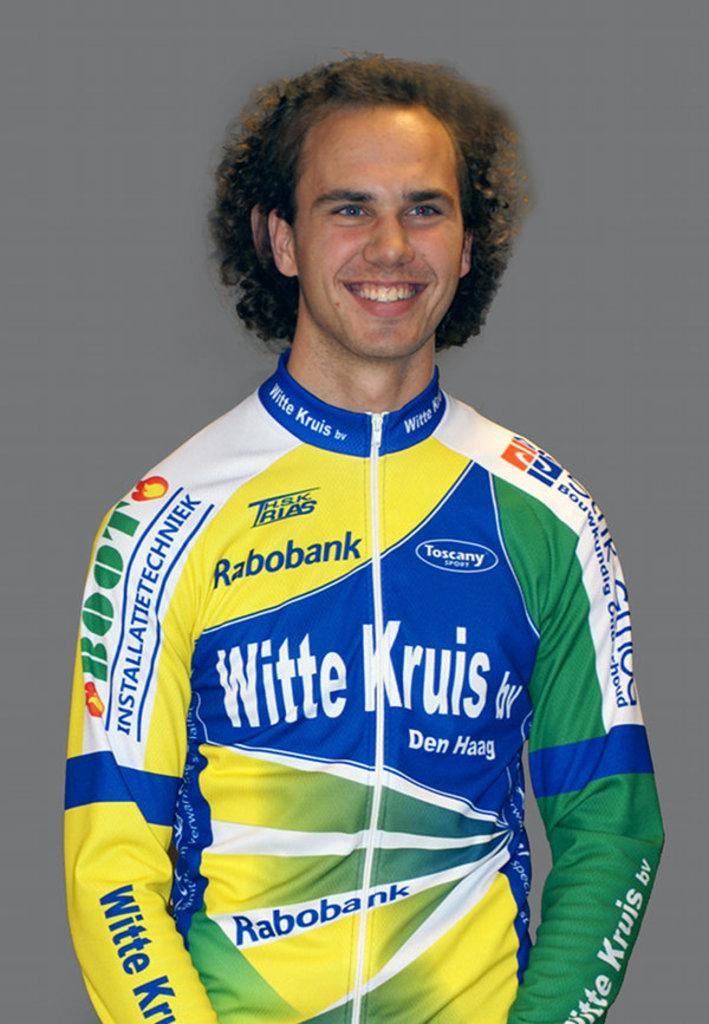<image>
Offer a succinct explanation of the picture presented. a man with a witte jruis shirt on his back 